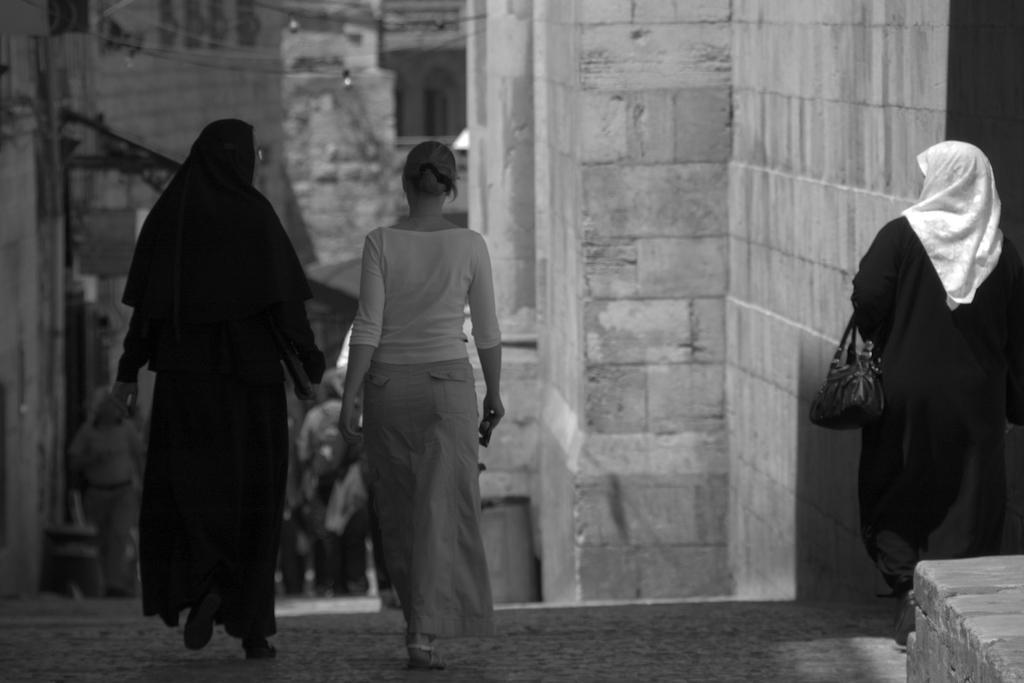Could you give a brief overview of what you see in this image? In this image two women are walking on the floor. Right side there is a woman carrying a bag is standing beside the wall. Few persons are walking on the stairs. Background there is wall. 